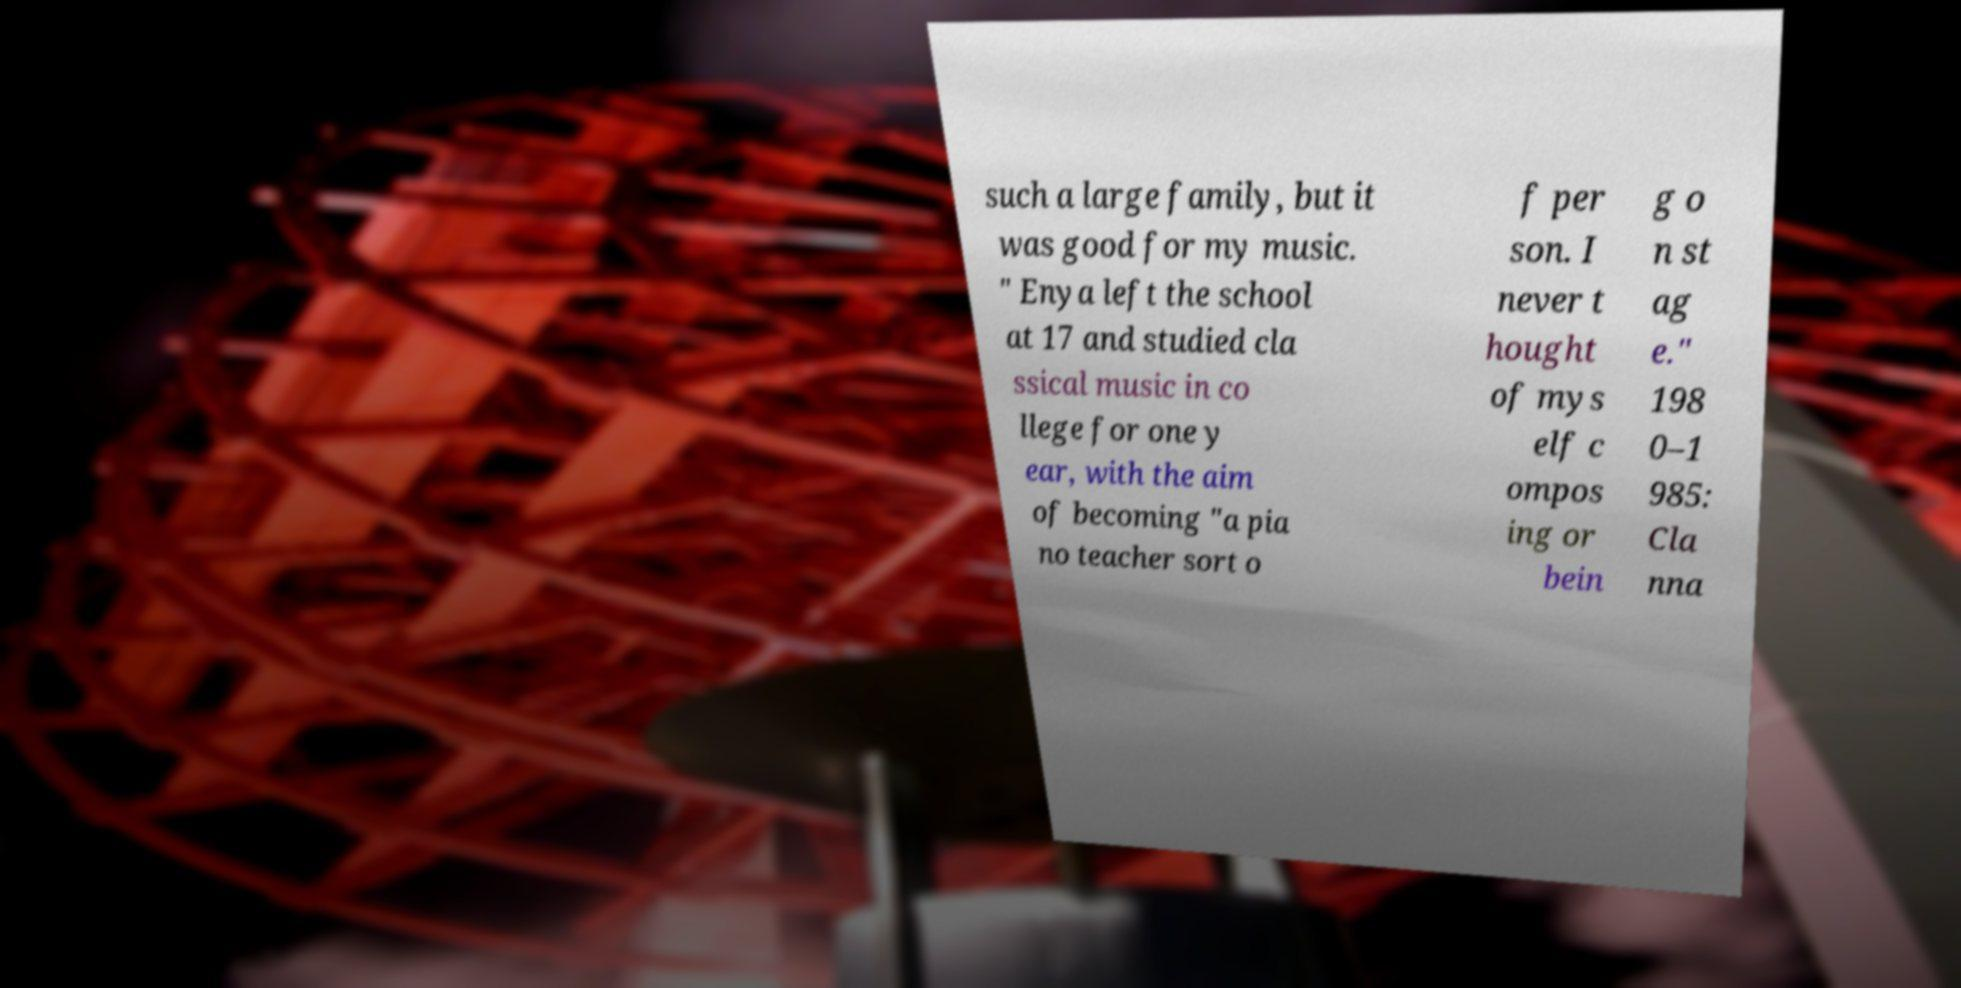Can you read and provide the text displayed in the image?This photo seems to have some interesting text. Can you extract and type it out for me? such a large family, but it was good for my music. " Enya left the school at 17 and studied cla ssical music in co llege for one y ear, with the aim of becoming "a pia no teacher sort o f per son. I never t hought of mys elf c ompos ing or bein g o n st ag e." 198 0–1 985: Cla nna 